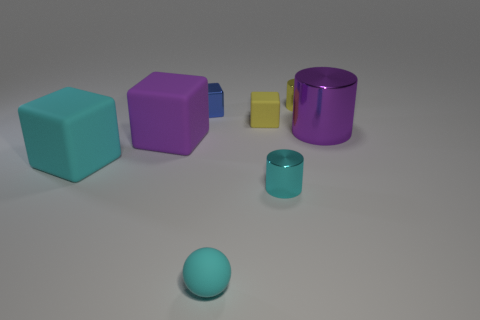What is the shape of the small rubber thing that is behind the purple thing that is right of the tiny matte cube?
Your answer should be compact. Cube. What size is the purple rubber block?
Offer a terse response. Large. What shape is the large cyan object?
Offer a terse response. Cube. Do the big metal object and the tiny cyan object that is behind the rubber ball have the same shape?
Keep it short and to the point. Yes. There is a thing to the right of the yellow cylinder; is it the same shape as the small cyan matte thing?
Offer a terse response. No. How many things are both left of the purple metallic cylinder and to the right of the tiny cyan metal cylinder?
Make the answer very short. 1. How many other things are the same size as the purple cube?
Offer a terse response. 2. Is the number of cubes that are to the right of the tiny cyan matte ball the same as the number of tiny yellow matte cubes?
Your answer should be very brief. Yes. There is a metallic cylinder that is behind the purple shiny thing; does it have the same color as the small rubber object behind the large purple metal object?
Keep it short and to the point. Yes. There is a cyan thing that is left of the tiny rubber cube and to the right of the small blue shiny cube; what is its material?
Provide a short and direct response. Rubber. 